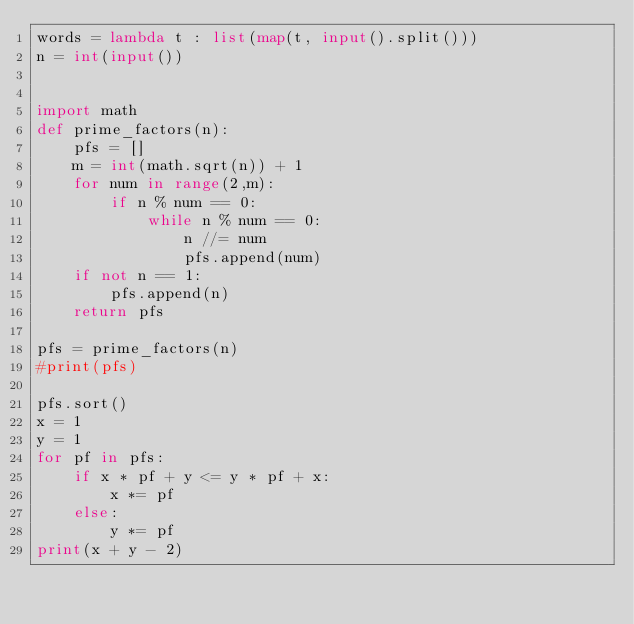Convert code to text. <code><loc_0><loc_0><loc_500><loc_500><_Python_>words = lambda t : list(map(t, input().split()))
n = int(input())


import math
def prime_factors(n):
    pfs = []
    m = int(math.sqrt(n)) + 1
    for num in range(2,m):
        if n % num == 0:
            while n % num == 0:
                n //= num
                pfs.append(num)
    if not n == 1:
        pfs.append(n)
    return pfs

pfs = prime_factors(n)
#print(pfs)

pfs.sort()
x = 1
y = 1
for pf in pfs:
    if x * pf + y <= y * pf + x:
        x *= pf
    else:
        y *= pf
print(x + y - 2)
</code> 